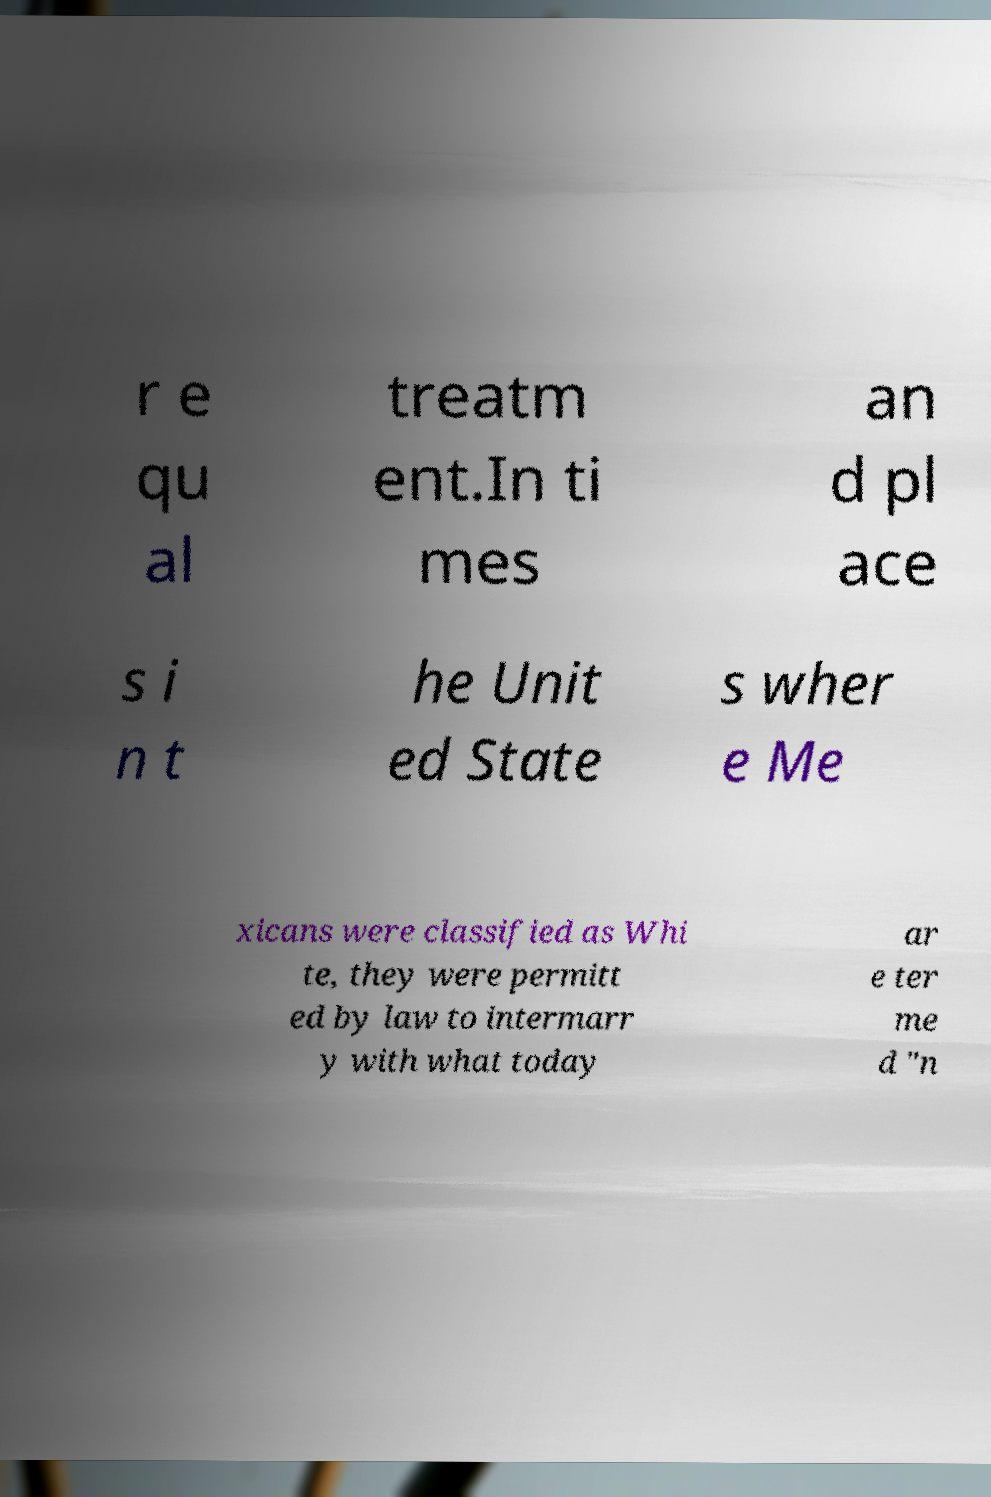What messages or text are displayed in this image? I need them in a readable, typed format. r e qu al treatm ent.In ti mes an d pl ace s i n t he Unit ed State s wher e Me xicans were classified as Whi te, they were permitt ed by law to intermarr y with what today ar e ter me d "n 